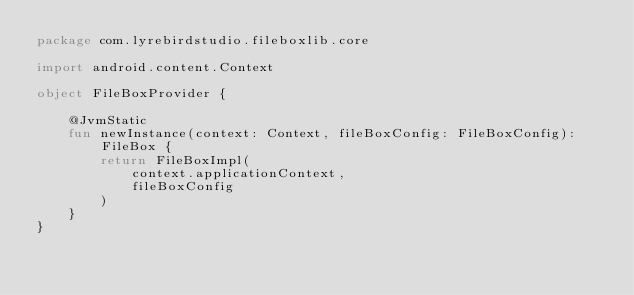Convert code to text. <code><loc_0><loc_0><loc_500><loc_500><_Kotlin_>package com.lyrebirdstudio.fileboxlib.core

import android.content.Context

object FileBoxProvider {

    @JvmStatic
    fun newInstance(context: Context, fileBoxConfig: FileBoxConfig): FileBox {
        return FileBoxImpl(
            context.applicationContext,
            fileBoxConfig
        )
    }
}</code> 